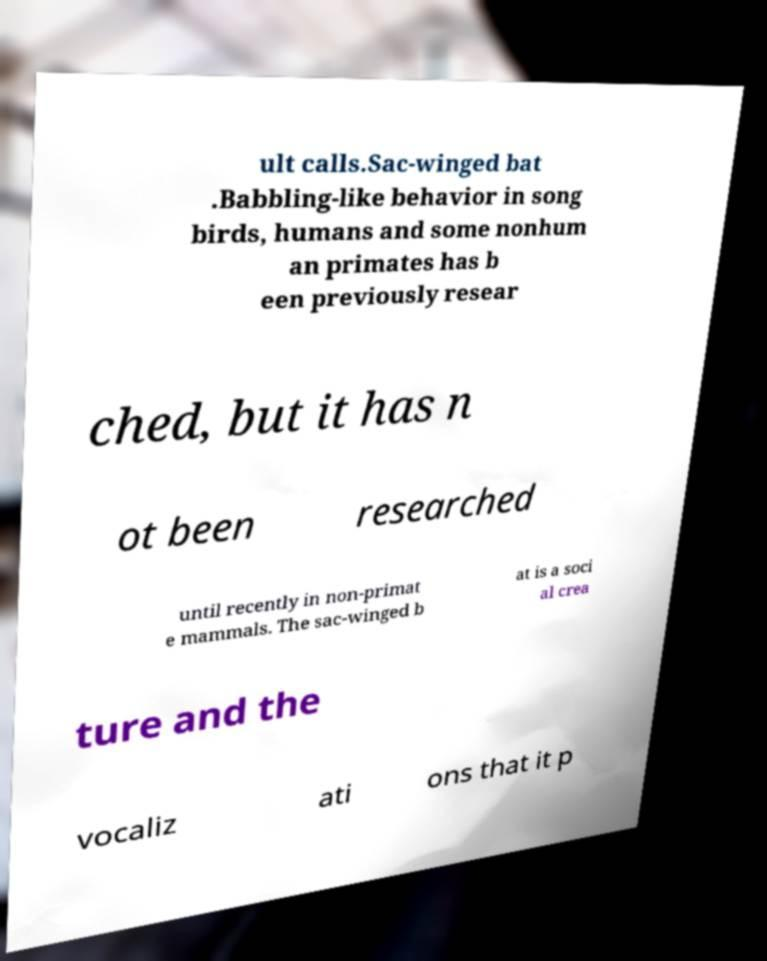There's text embedded in this image that I need extracted. Can you transcribe it verbatim? ult calls.Sac-winged bat .Babbling-like behavior in song birds, humans and some nonhum an primates has b een previously resear ched, but it has n ot been researched until recently in non-primat e mammals. The sac-winged b at is a soci al crea ture and the vocaliz ati ons that it p 